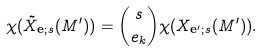<formula> <loc_0><loc_0><loc_500><loc_500>\chi ( \tilde { X } _ { \mathbf e ; s } ( M ^ { \prime } ) ) = \binom { s } { e _ { k } } \chi ( X _ { \mathbf e ^ { \prime } ; s } ( M ^ { \prime } ) ) .</formula> 